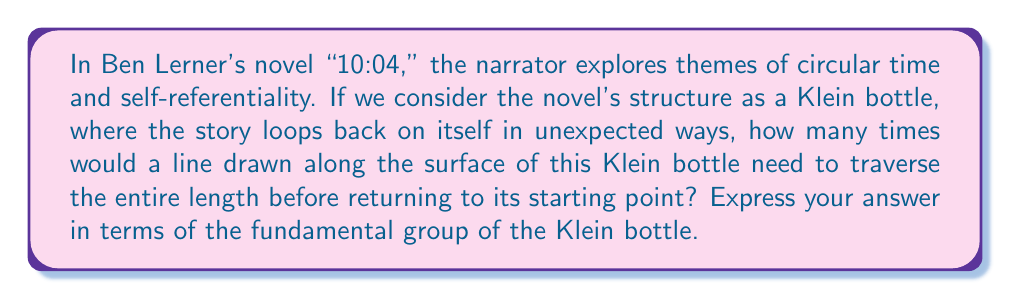Solve this math problem. To approach this problem, let's break it down into steps:

1) First, recall that a Klein bottle is a non-orientable surface with no boundary. It's similar to a Möbius strip but closed.

2) The fundamental group of a Klein bottle, denoted as $\pi_1(\text{Klein bottle})$, is isomorphic to:

   $$\pi_1(\text{Klein bottle}) \cong \langle a, b \mid aba^{-1}b \rangle$$

   Where $a$ and $b$ are the generators of the group.

3) In terms of the surface, $a$ can be thought of as a loop around the "tube" of the Klein bottle, while $b$ represents a path from one end to the other.

4) The relation $aba^{-1}b$ means that going around the tube, then from end to end, then around the tube in the opposite direction, and finally from end to end again, is equivalent to doing nothing (i.e., returning to the starting point).

5) Now, consider a line drawn along the surface. To return to its starting point, it needs to complete both a full circuit around the "tube" and a full traverse from one end to the other.

6) In terms of the fundamental group, this is equivalent to the product $ab$.

7) However, unlike on a torus, a single $ab$ doesn't bring us back to the starting point on a Klein bottle. We need to do this twice.

8) This is because $$(ab)^2 = abab = a(ba)b = a(a^{-1}b^{-1})b = (aa^{-1})(b^{-1}b) = e$$

   Where $e$ is the identity element of the group.

Therefore, a line needs to traverse the entire length of the Klein bottle twice before returning to its starting point.
Answer: The line needs to traverse the Klein bottle twice, which can be expressed in terms of the fundamental group as $(ab)^2$, where $a$ and $b$ are the generators of $\pi_1(\text{Klein bottle})$. 